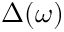Convert formula to latex. <formula><loc_0><loc_0><loc_500><loc_500>\Delta ( \omega )</formula> 